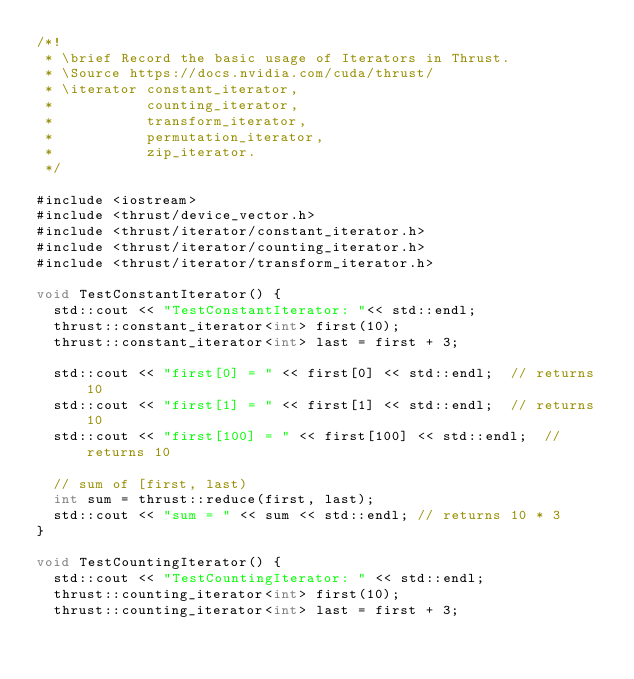<code> <loc_0><loc_0><loc_500><loc_500><_Cuda_>/*!
 * \brief Record the basic usage of Iterators in Thrust.
 * \Source https://docs.nvidia.com/cuda/thrust/
 * \iterator constant_iterator, 
 *           counting_iterator,
 *           transform_iterator,  
 *           permutation_iterator,
 *           zip_iterator.
 */

#include <iostream>
#include <thrust/device_vector.h>
#include <thrust/iterator/constant_iterator.h>
#include <thrust/iterator/counting_iterator.h>
#include <thrust/iterator/transform_iterator.h>

void TestConstantIterator() {
  std::cout << "TestConstantIterator: "<< std::endl;
  thrust::constant_iterator<int> first(10);
  thrust::constant_iterator<int> last = first + 3;

  std::cout << "first[0] = " << first[0] << std::endl;  // returns 10
  std::cout << "first[1] = " << first[1] << std::endl;  // returns 10
  std::cout << "first[100] = " << first[100] << std::endl;  // returns 10

  // sum of [first, last)
  int sum = thrust::reduce(first, last);
  std::cout << "sum = " << sum << std::endl; // returns 10 * 3
}

void TestCountingIterator() {
  std::cout << "TestCountingIterator: " << std::endl;
  thrust::counting_iterator<int> first(10);
  thrust::counting_iterator<int> last = first + 3;
</code> 